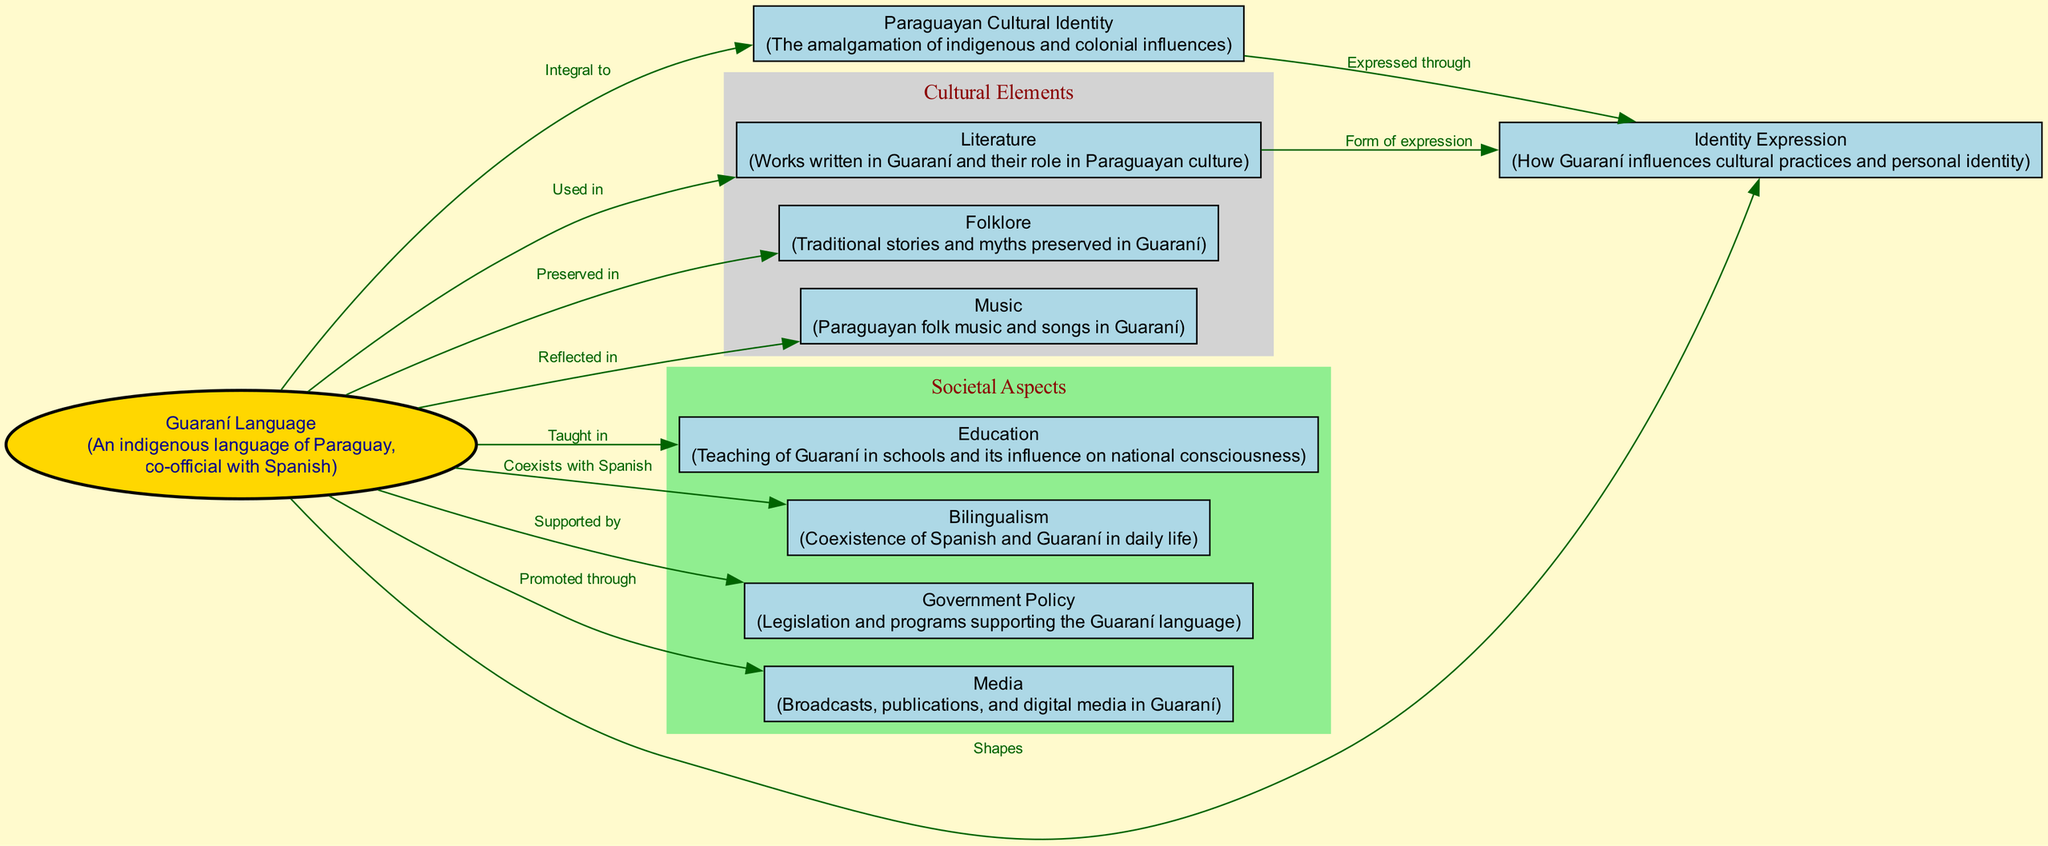What is the central node of the diagram? The central node is identified as "Guaraní Language." It stands out visually since it has a different shape (ellipse) and color (gold), indicating its importance in the context of the concept map.
Answer: Guaraní Language How many nodes are there in total? The diagram lists 10 distinct nodes, which are the elements that connect different aspects of Guaraní language and Paraguayan cultural identity. Each node represents a key concept or component in the overall mapping.
Answer: 10 Which nodes are associated with "Education"? The node "Education" is connected to "Guaraní Language" through the label "Taught in." This indicates that education plays a significant role in the dissemination and teaching of the Guaraní language within society.
Answer: Guaraní Language What relationship does "Bilingualism" have with "Guaraní Language"? The diagram shows that "Bilingualism" is linked to "Guaraní Language" with the label "Coexists with Spanish." This means that both languages are present simultaneously in daily life, highlighting an aspect of cultural identity.
Answer: Coexists with Spanish How does "Guaraní Language" influence "Paraguayan Cultural Identity"? According to the diagram, "Guaraní Language" is labeled as "Integral to" "Paraguayan Cultural Identity." This signifies the essential role that the Guaraní language plays in shaping the cultural identity of Paraguayans, incorporating both indigenous and colonial elements.
Answer: Integral to What role does "Literature" play in "Identity Expression"? The diagram indicates that "Literature" is a "Form of expression" for "Identity Expression." This suggests that literary works written in Guaraní provide a medium through which individuals express their cultural identity and personal experiences.
Answer: Form of expression How are traditional stories related to "Guaraní Language"? "Traditional stories and myths" are preserved in the context of "Folklore," which in turn is linked to "Guaraní Language" by the label "Preserved in." This illustrates how the language serves as a vessel for cultural narratives.
Answer: Preserved in What is promoted through "Guaraní Language"? The linkage shows that "Guaraní Language" is "Promoted through" media, which includes broadcasts and publications in Guaraní, signifying the role of media in maintaining and fostering Guaraní language use.
Answer: Media 